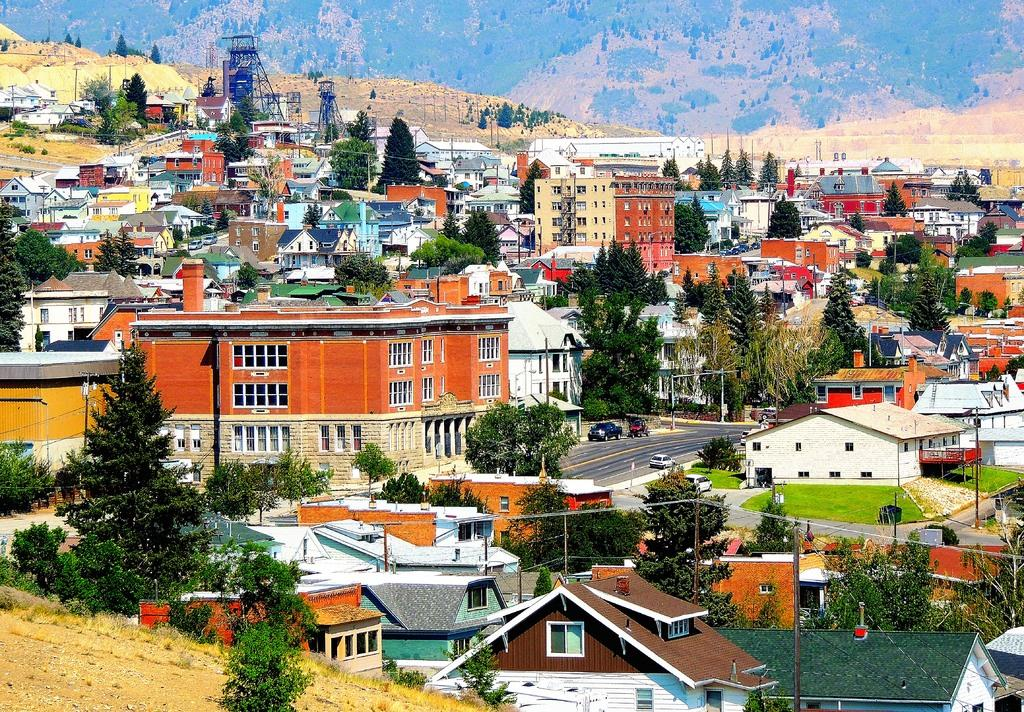What type of location is shown in the image? The image depicts a city. What types of structures can be seen in the city? There are houses and buildings in the city. Are there any natural elements present in the city? Yes, trees are present in the city. How are the different parts of the city connected? Roads are visible in the city, which connect the various structures and areas. What can be seen in the background of the image? There is a mountain in the background of the image. What riddle is being solved by the people in the city? There is no riddle being solved by the people in the image; it simply depicts a city with various structures and elements. Can you provide an example of a market in the city? There is no market specifically shown in the image, so it's not possible to provide an example. 